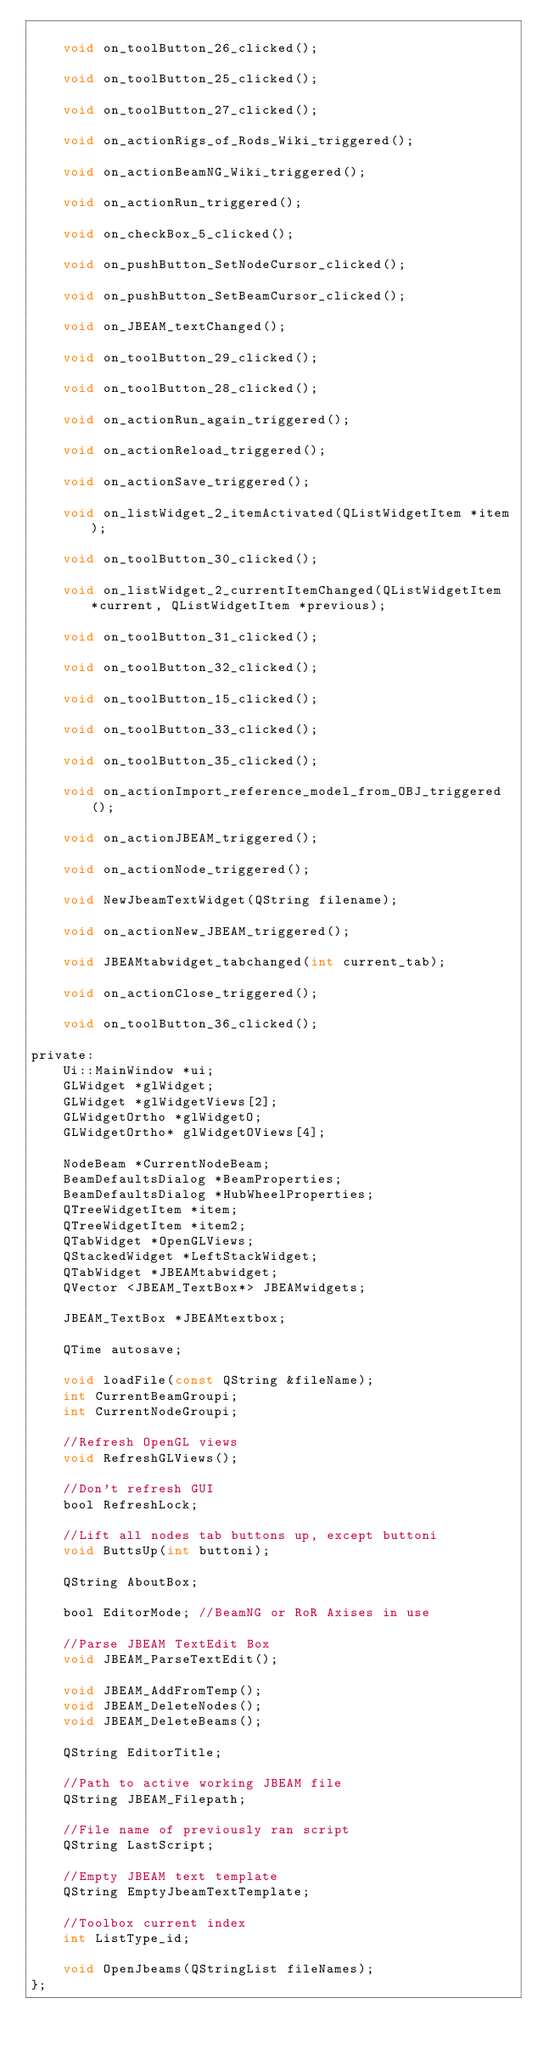Convert code to text. <code><loc_0><loc_0><loc_500><loc_500><_C_>
    void on_toolButton_26_clicked();

    void on_toolButton_25_clicked();

    void on_toolButton_27_clicked();

    void on_actionRigs_of_Rods_Wiki_triggered();

    void on_actionBeamNG_Wiki_triggered();

    void on_actionRun_triggered();

    void on_checkBox_5_clicked();

    void on_pushButton_SetNodeCursor_clicked();

    void on_pushButton_SetBeamCursor_clicked();

    void on_JBEAM_textChanged();

    void on_toolButton_29_clicked();

    void on_toolButton_28_clicked();

    void on_actionRun_again_triggered();

    void on_actionReload_triggered();

    void on_actionSave_triggered();

    void on_listWidget_2_itemActivated(QListWidgetItem *item);

    void on_toolButton_30_clicked();

    void on_listWidget_2_currentItemChanged(QListWidgetItem *current, QListWidgetItem *previous);

    void on_toolButton_31_clicked();

    void on_toolButton_32_clicked();

    void on_toolButton_15_clicked();

    void on_toolButton_33_clicked();

    void on_toolButton_35_clicked();

    void on_actionImport_reference_model_from_OBJ_triggered();

    void on_actionJBEAM_triggered();

    void on_actionNode_triggered();

    void NewJbeamTextWidget(QString filename);

    void on_actionNew_JBEAM_triggered();

    void JBEAMtabwidget_tabchanged(int current_tab);

    void on_actionClose_triggered();

    void on_toolButton_36_clicked();

private:
    Ui::MainWindow *ui;
    GLWidget *glWidget;
    GLWidget *glWidgetViews[2];
    GLWidgetOrtho *glWidgetO;
    GLWidgetOrtho* glWidgetOViews[4];

    NodeBeam *CurrentNodeBeam;
    BeamDefaultsDialog *BeamProperties;
    BeamDefaultsDialog *HubWheelProperties;
    QTreeWidgetItem *item;
    QTreeWidgetItem *item2;
    QTabWidget *OpenGLViews;
    QStackedWidget *LeftStackWidget;
    QTabWidget *JBEAMtabwidget;
    QVector <JBEAM_TextBox*> JBEAMwidgets;

    JBEAM_TextBox *JBEAMtextbox;

    QTime autosave;

    void loadFile(const QString &fileName);
    int CurrentBeamGroupi;
    int CurrentNodeGroupi;

    //Refresh OpenGL views
    void RefreshGLViews();

    //Don't refresh GUI
    bool RefreshLock;

    //Lift all nodes tab buttons up, except buttoni
    void ButtsUp(int buttoni);

    QString AboutBox;

    bool EditorMode; //BeamNG or RoR Axises in use

    //Parse JBEAM TextEdit Box
    void JBEAM_ParseTextEdit();

    void JBEAM_AddFromTemp();
    void JBEAM_DeleteNodes();
    void JBEAM_DeleteBeams();

    QString EditorTitle;

    //Path to active working JBEAM file
    QString JBEAM_Filepath;

    //File name of previously ran script
    QString LastScript;

    //Empty JBEAM text template
    QString EmptyJbeamTextTemplate;

    //Toolbox current index
    int ListType_id;

    void OpenJbeams(QStringList fileNames);
};


</code> 